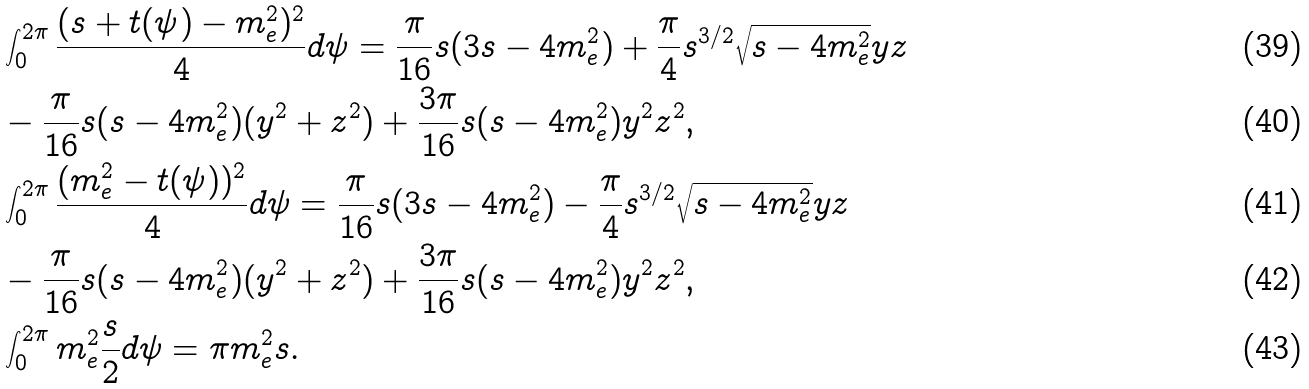Convert formula to latex. <formula><loc_0><loc_0><loc_500><loc_500>& \int _ { 0 } ^ { 2 \pi } \frac { ( s + t ( \psi ) - m _ { e } ^ { 2 } ) ^ { 2 } } { 4 } d \psi = \frac { \pi } { 1 6 } s ( 3 s - 4 m _ { e } ^ { 2 } ) + \frac { \pi } { 4 } s ^ { 3 / 2 } \sqrt { s - 4 m _ { e } ^ { 2 } } y z \\ & - \frac { \pi } { 1 6 } s ( s - 4 m _ { e } ^ { 2 } ) ( y ^ { 2 } + z ^ { 2 } ) + \frac { 3 \pi } { 1 6 } s ( s - 4 m _ { e } ^ { 2 } ) y ^ { 2 } z ^ { 2 } , \\ & \int _ { 0 } ^ { 2 \pi } \frac { ( m _ { e } ^ { 2 } - t ( \psi ) ) ^ { 2 } } { 4 } d \psi = \frac { \pi } { 1 6 } s ( 3 s - 4 m _ { e } ^ { 2 } ) - \frac { \pi } { 4 } s ^ { 3 / 2 } \sqrt { s - 4 m _ { e } ^ { 2 } } y z \\ & - \frac { \pi } { 1 6 } s ( s - 4 m _ { e } ^ { 2 } ) ( y ^ { 2 } + z ^ { 2 } ) + \frac { 3 \pi } { 1 6 } s ( s - 4 m _ { e } ^ { 2 } ) y ^ { 2 } z ^ { 2 } , \\ & \int _ { 0 } ^ { 2 \pi } m _ { e } ^ { 2 } \frac { s } { 2 } d \psi = \pi m _ { e } ^ { 2 } s .</formula> 